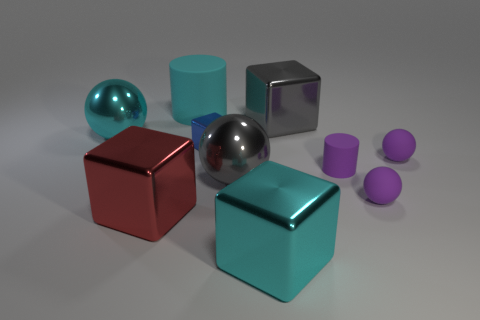Subtract all blocks. How many objects are left? 6 Subtract 0 brown spheres. How many objects are left? 10 Subtract all purple objects. Subtract all large shiny blocks. How many objects are left? 4 Add 4 gray metallic balls. How many gray metallic balls are left? 5 Add 7 big cyan shiny blocks. How many big cyan shiny blocks exist? 8 